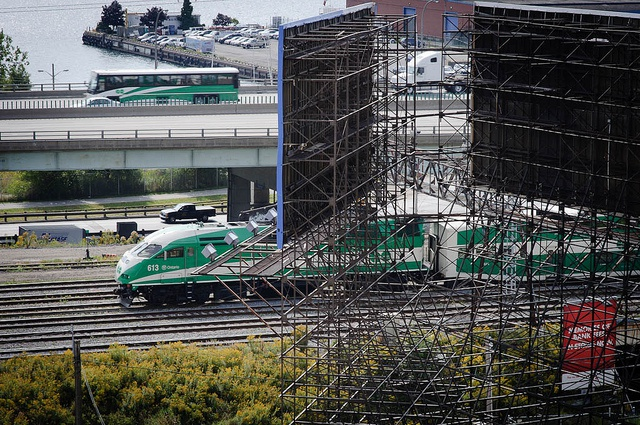Describe the objects in this image and their specific colors. I can see train in lightgray, black, teal, and darkgray tones, bus in lightgray, teal, black, gray, and darkgray tones, truck in lightgray, darkgray, and gray tones, truck in lightgray, gray, darkgray, and olive tones, and truck in lightgray, black, gray, and darkgray tones in this image. 